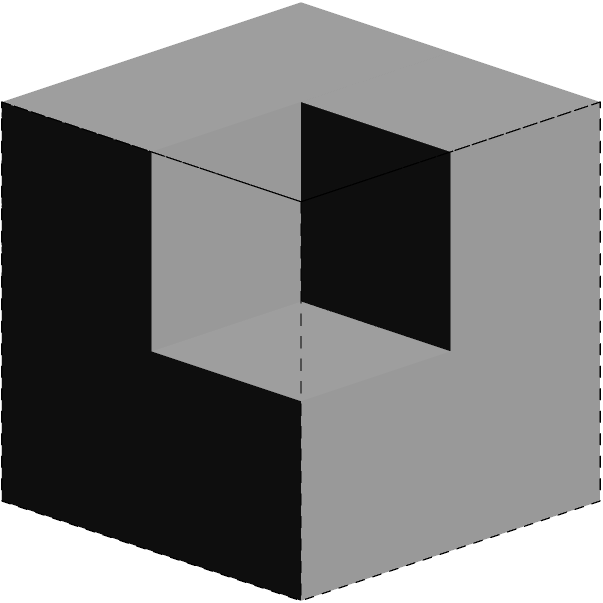As a retired medical professional with experience in analyzing complex structures, consider the 3D arrangement of cubes shown above. The structure is presented with front, top, and side views. Based on these perspectives, how many cubes are present in the complete structure? Let's approach this step-by-step, utilizing our spatial reasoning skills:

1. Front view analysis:
   - We can see a 2x2 grid of cubes from the front.
   - This accounts for 4 cubes.

2. Top view analysis:
   - The top view shows a 2x2 grid as well.
   - However, we notice that one cube is missing in the top-right corner.
   - This suggests there are 3 cubes visible from the top.

3. Side view analysis:
   - The side view shows a 2x1 grid.
   - This confirms that the back row is complete, while the front row is missing a cube on top.

4. Combining the information:
   - The bottom layer is complete with 4 cubes (2x2).
   - The top layer has 3 cubes, missing one in the top-right corner.

5. Final count:
   - Bottom layer: 4 cubes
   - Top layer: 3 cubes
   - Total: 4 + 3 = 7 cubes

This analysis demonstrates how examining multiple perspectives can provide a comprehensive understanding of a 3D structure, much like how medical imaging from different angles helps in diagnosing complex conditions.
Answer: 7 cubes 